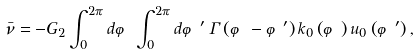Convert formula to latex. <formula><loc_0><loc_0><loc_500><loc_500>\bar { \nu } = - G _ { 2 } \int _ { 0 } ^ { 2 \pi } d \varphi \int _ { 0 } ^ { 2 \pi } d \varphi ^ { \prime } \, \Gamma \left ( \varphi - \varphi ^ { \prime } \right ) k _ { 0 } \left ( \varphi \right ) u _ { 0 } \left ( \varphi ^ { \prime } \right ) ,</formula> 